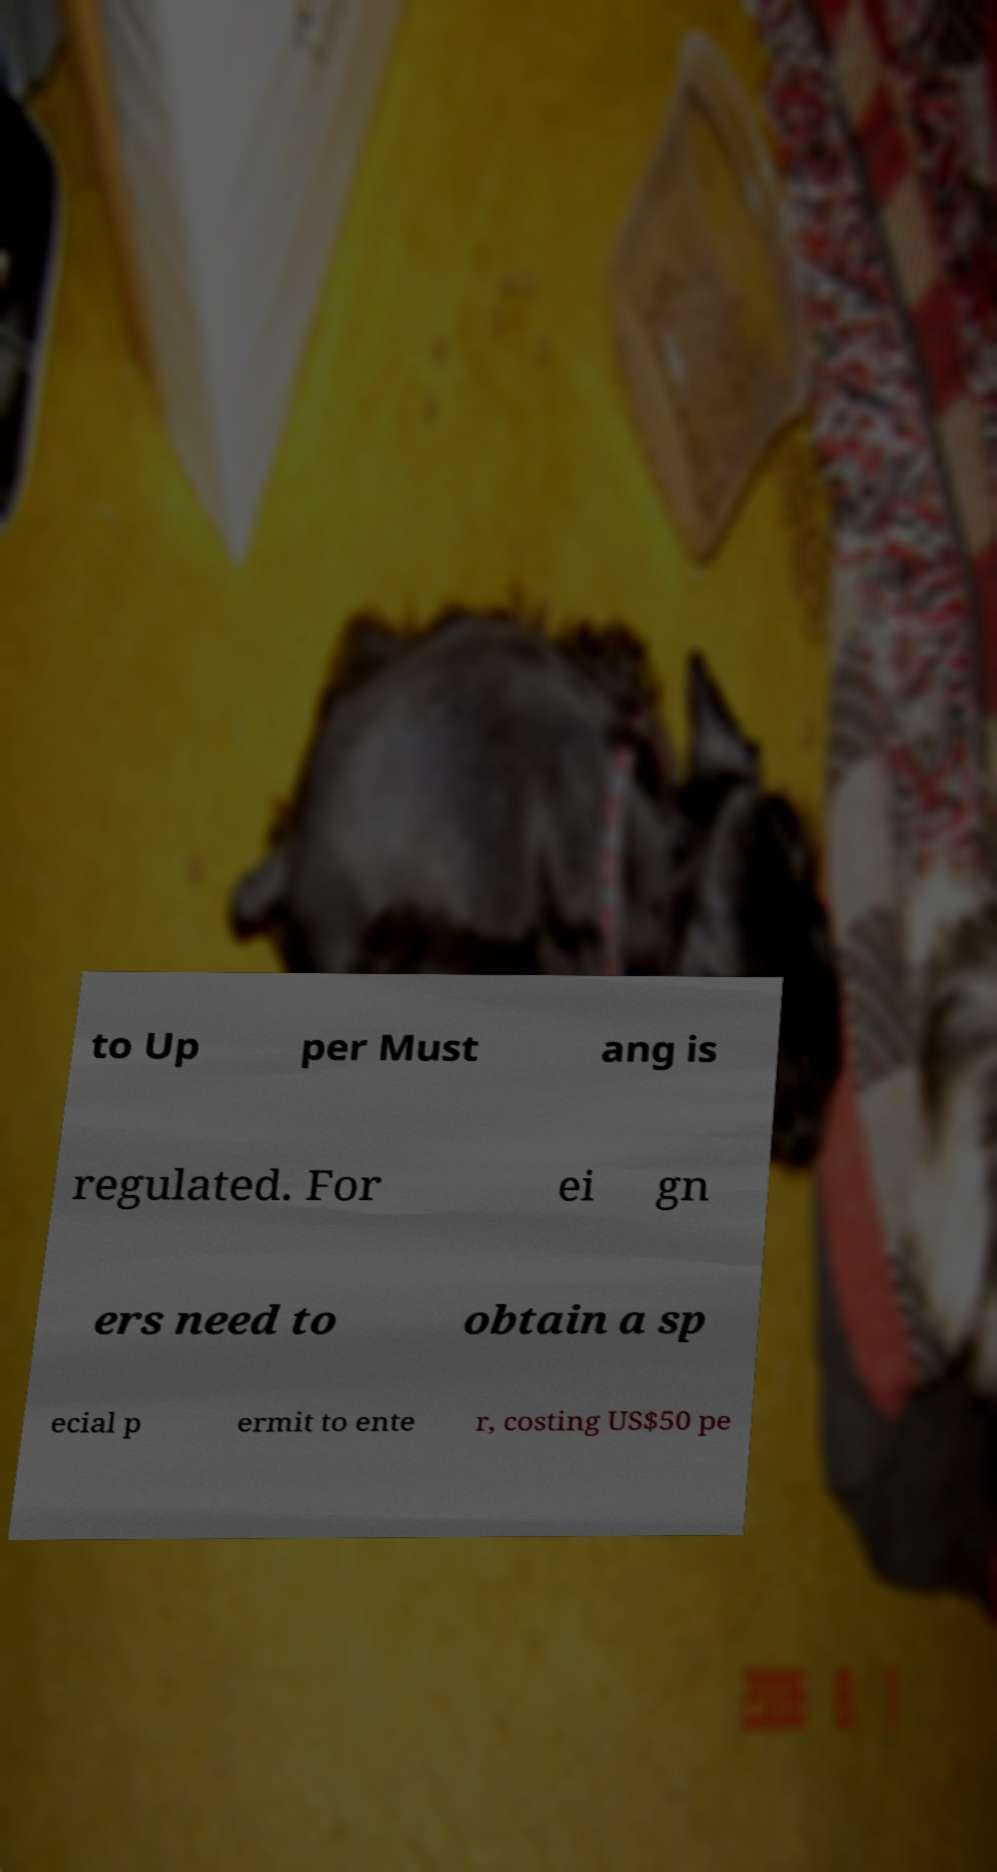I need the written content from this picture converted into text. Can you do that? to Up per Must ang is regulated. For ei gn ers need to obtain a sp ecial p ermit to ente r, costing US$50 pe 